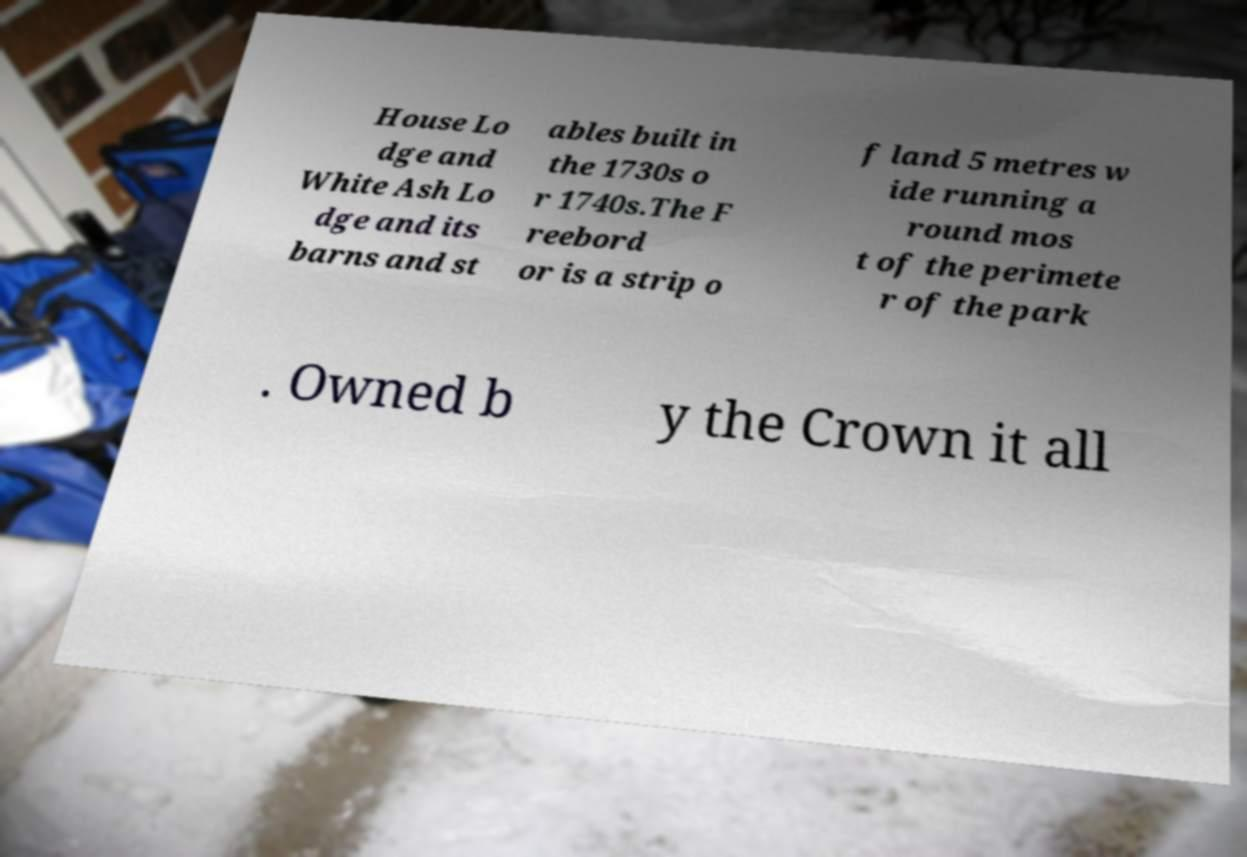I need the written content from this picture converted into text. Can you do that? House Lo dge and White Ash Lo dge and its barns and st ables built in the 1730s o r 1740s.The F reebord or is a strip o f land 5 metres w ide running a round mos t of the perimete r of the park . Owned b y the Crown it all 